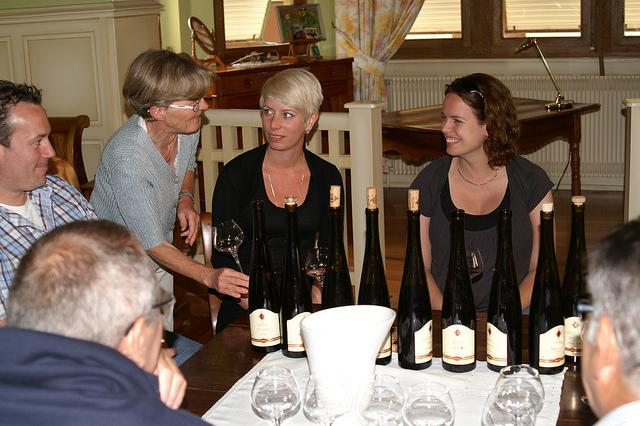What is in the bottle all the way to the right that is near the brunette woman? Please explain your reasoning. cork. The bottle to the left is corked. 